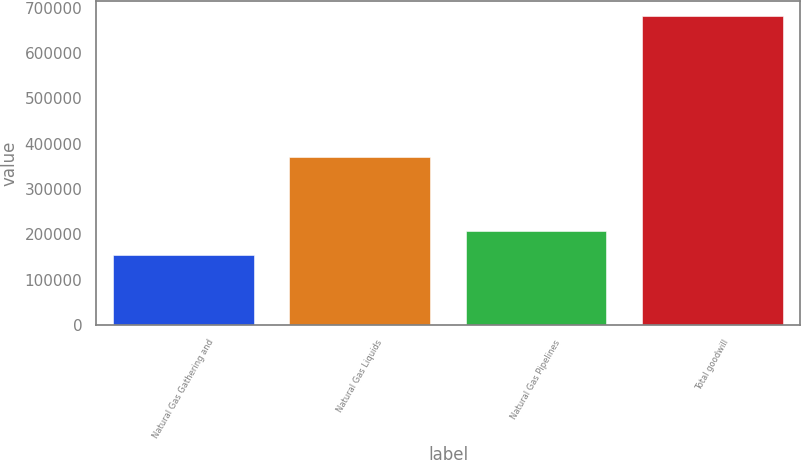Convert chart to OTSL. <chart><loc_0><loc_0><loc_500><loc_500><bar_chart><fcel>Natural Gas Gathering and<fcel>Natural Gas Liquids<fcel>Natural Gas Pipelines<fcel>Total goodwill<nl><fcel>153404<fcel>371217<fcel>206174<fcel>681100<nl></chart> 